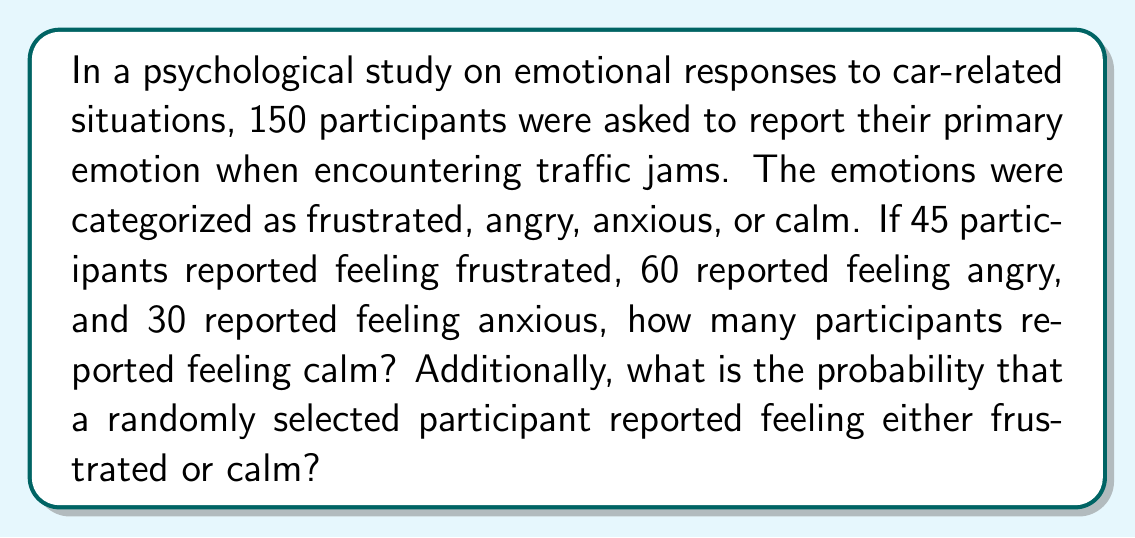Solve this math problem. Let's approach this step-by-step:

1) First, let's define our variables:
   $f$ = frustrated, $a$ = angry, $x$ = anxious, $c$ = calm

2) We know the total number of participants:
   $f + a + x + c = 150$

3) We're given the values for frustrated, angry, and anxious:
   $f = 45$, $a = 60$, $x = 30$

4) To find the number of calm participants, we substitute these values:
   $45 + 60 + 30 + c = 150$
   $135 + c = 150$
   $c = 150 - 135 = 15$

5) Now, to calculate the probability of a randomly selected participant feeling either frustrated or calm:
   
   $P(\text{frustrated or calm}) = \frac{\text{number of frustrated or calm participants}}{\text{total number of participants}}$

   $P(\text{frustrated or calm}) = \frac{f + c}{150} = \frac{45 + 15}{150} = \frac{60}{150} = \frac{2}{5} = 0.4$
Answer: 15 participants; $\frac{2}{5}$ or 0.4 